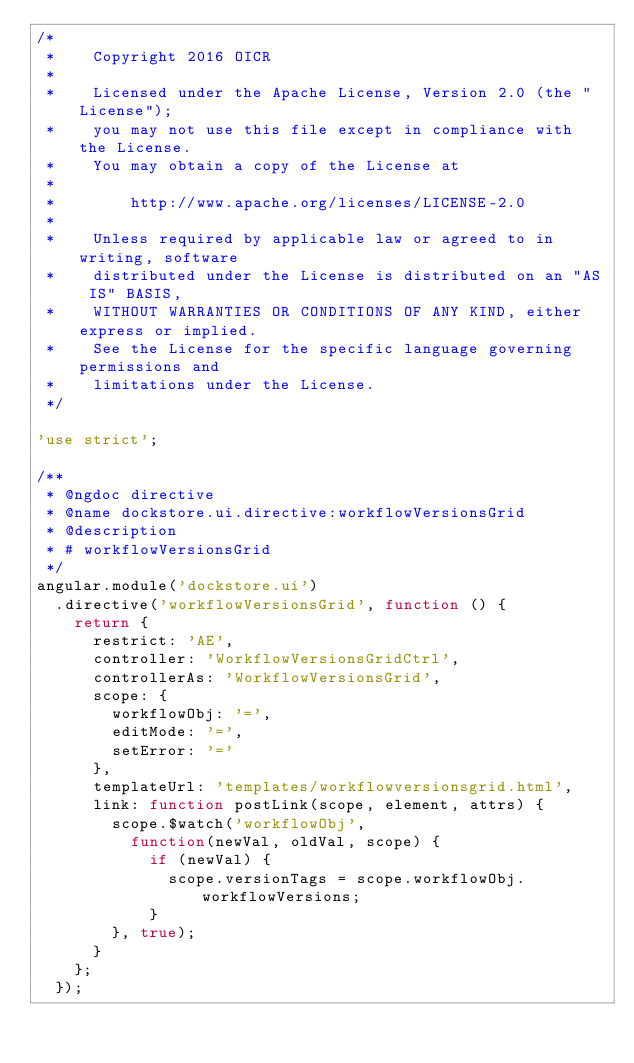<code> <loc_0><loc_0><loc_500><loc_500><_JavaScript_>/*
 *    Copyright 2016 OICR
 *
 *    Licensed under the Apache License, Version 2.0 (the "License");
 *    you may not use this file except in compliance with the License.
 *    You may obtain a copy of the License at
 *
 *        http://www.apache.org/licenses/LICENSE-2.0
 *
 *    Unless required by applicable law or agreed to in writing, software
 *    distributed under the License is distributed on an "AS IS" BASIS,
 *    WITHOUT WARRANTIES OR CONDITIONS OF ANY KIND, either express or implied.
 *    See the License for the specific language governing permissions and
 *    limitations under the License.
 */

'use strict';

/**
 * @ngdoc directive
 * @name dockstore.ui.directive:workflowVersionsGrid
 * @description
 * # workflowVersionsGrid
 */
angular.module('dockstore.ui')
  .directive('workflowVersionsGrid', function () {
    return {
      restrict: 'AE',
      controller: 'WorkflowVersionsGridCtrl',
      controllerAs: 'WorkflowVersionsGrid',
      scope: {
      	workflowObj: '=',
        editMode: '=',
        setError: '='
      },
      templateUrl: 'templates/workflowversionsgrid.html',
      link: function postLink(scope, element, attrs) {
        scope.$watch('workflowObj',
          function(newVal, oldVal, scope) {
            if (newVal) {
              scope.versionTags = scope.workflowObj.workflowVersions;
            }
        }, true);
      }
    };
  });
</code> 